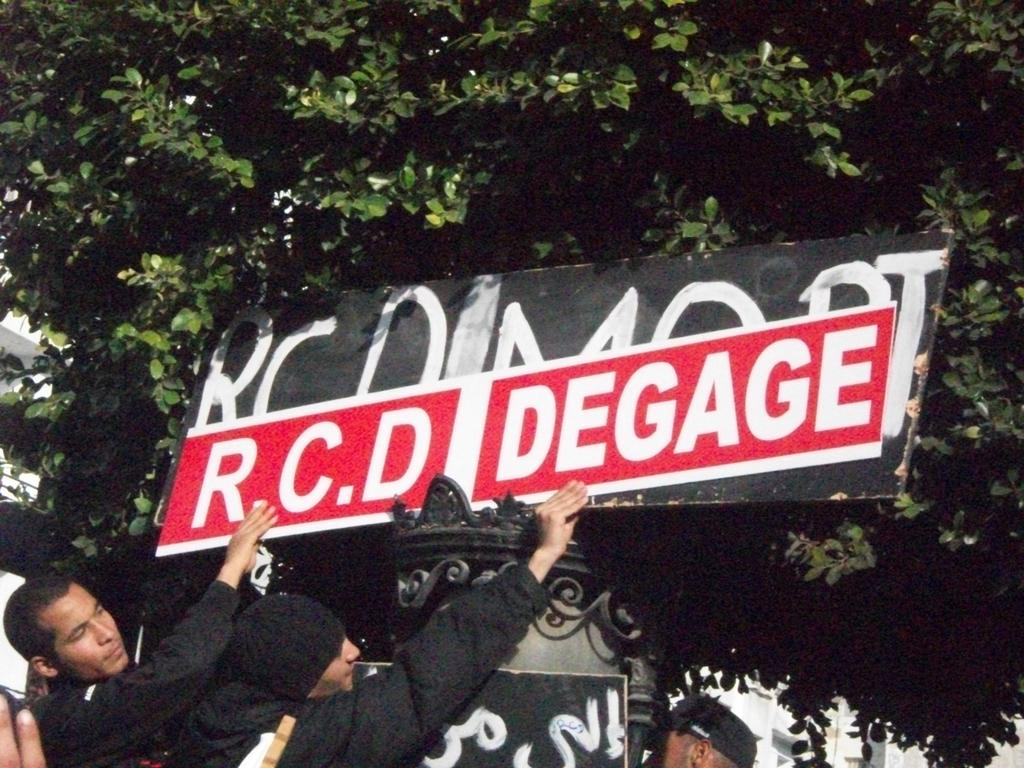How many people are in the image? There are two men in the image. What are the men holding in the image? The men are holding a black and red color board. What can be seen on the board? There is text on the board. What is visible in the background of the image? There are trees in the background of the image. What type of cheese is being used to write the text on the board? There is no cheese present in the image; the text is written on a color board. How many chickens can be seen in the image? There are no chickens present in the image. 